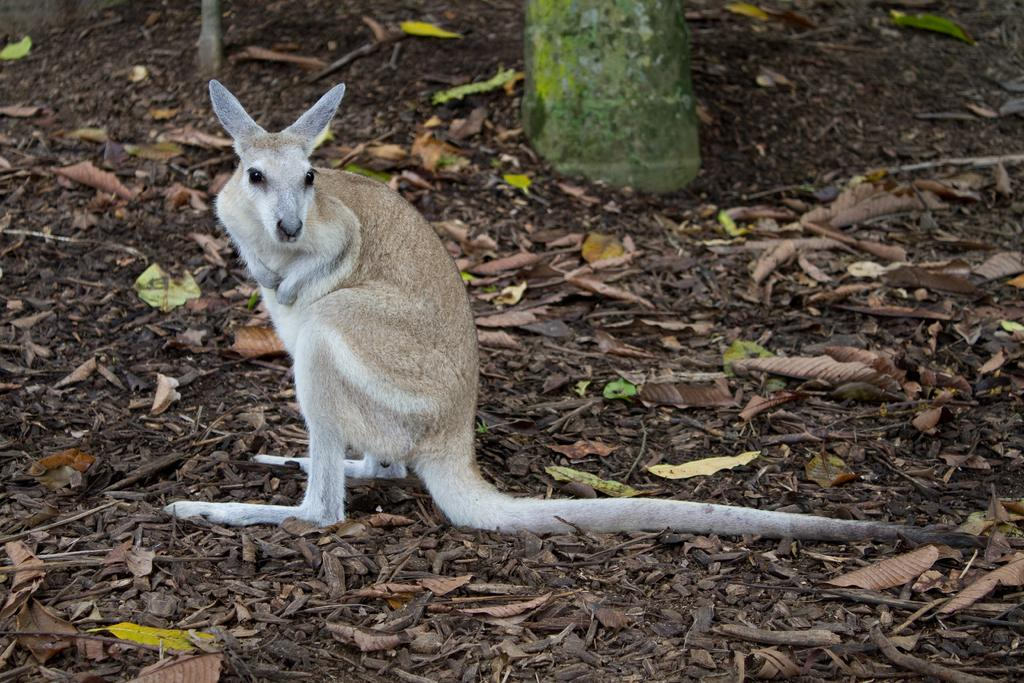What animal is present in the image? There is a kangaroo in the image. What can be seen on the ground in the image? There are dried leaves on the ground in the image. What part of a tree is visible at the top of the image? There appears to be a tree trunk at the top of the image. What is the square example of the kangaroo's income in the image? There is no square, example, or income mentioned or depicted in the image. The image features a kangaroo, dried leaves on the ground, and a tree trunk. 